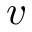<formula> <loc_0><loc_0><loc_500><loc_500>v</formula> 